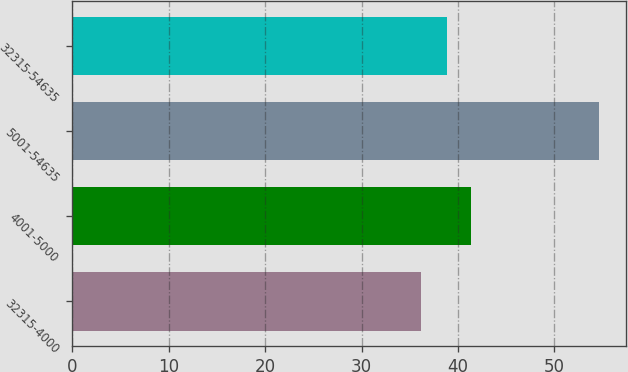Convert chart to OTSL. <chart><loc_0><loc_0><loc_500><loc_500><bar_chart><fcel>32315-4000<fcel>4001-5000<fcel>5001-54635<fcel>32315-54635<nl><fcel>36.12<fcel>41.36<fcel>54.64<fcel>38.84<nl></chart> 